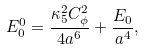Convert formula to latex. <formula><loc_0><loc_0><loc_500><loc_500>E _ { 0 } ^ { 0 } = \frac { \kappa _ { 5 } ^ { 2 } C _ { \phi } ^ { 2 } } { 4 a ^ { 6 } } + \frac { E _ { 0 } } { a ^ { 4 } } ,</formula> 